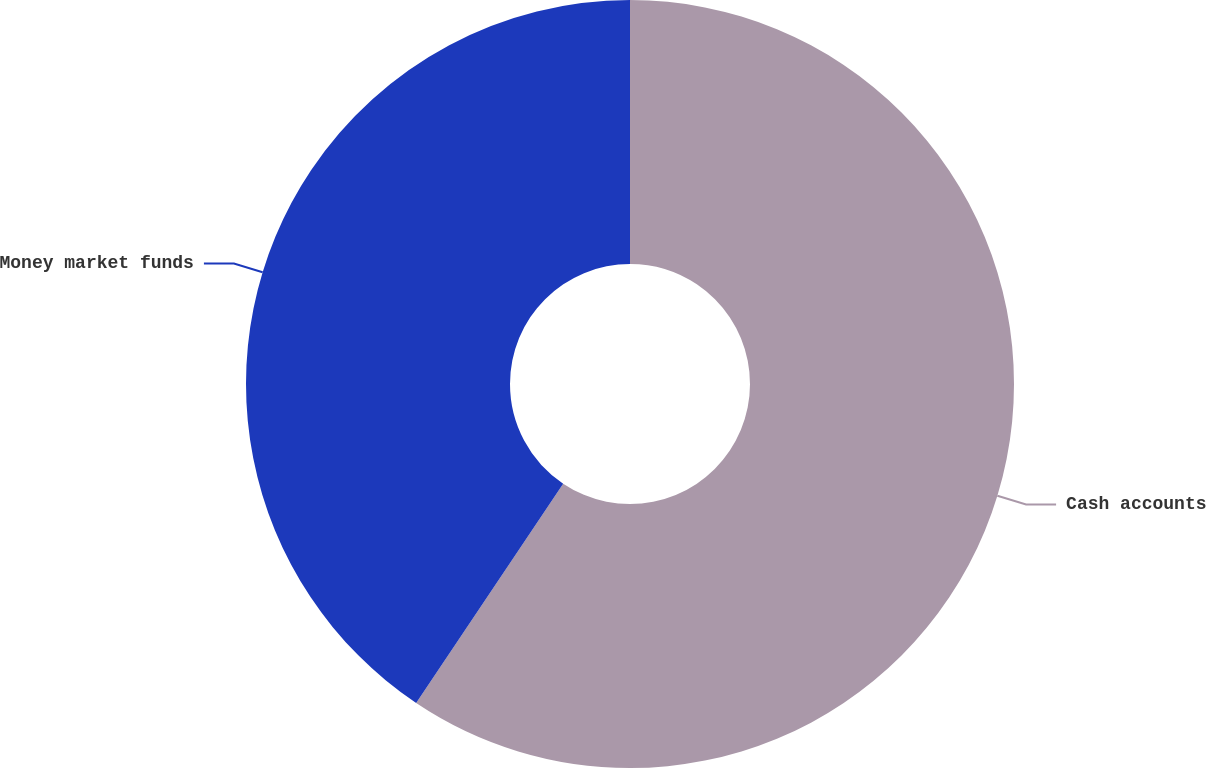Convert chart. <chart><loc_0><loc_0><loc_500><loc_500><pie_chart><fcel>Cash accounts<fcel>Money market funds<nl><fcel>59.4%<fcel>40.6%<nl></chart> 